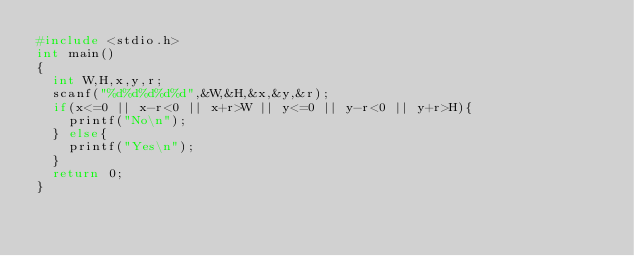<code> <loc_0><loc_0><loc_500><loc_500><_C_>#include <stdio.h>
int main()
{
  int W,H,x,y,r;
  scanf("%d%d%d%d%d",&W,&H,&x,&y,&r);
  if(x<=0 || x-r<0 || x+r>W || y<=0 || y-r<0 || y+r>H){
    printf("No\n");
  } else{
    printf("Yes\n");
  }
  return 0;
}</code> 